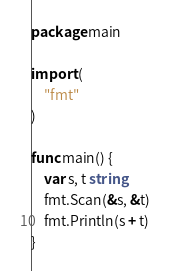<code> <loc_0><loc_0><loc_500><loc_500><_Go_>package main

import (
	"fmt"
)

func main() {
	var s, t string
	fmt.Scan(&s, &t)
	fmt.Println(s + t)
}
</code> 